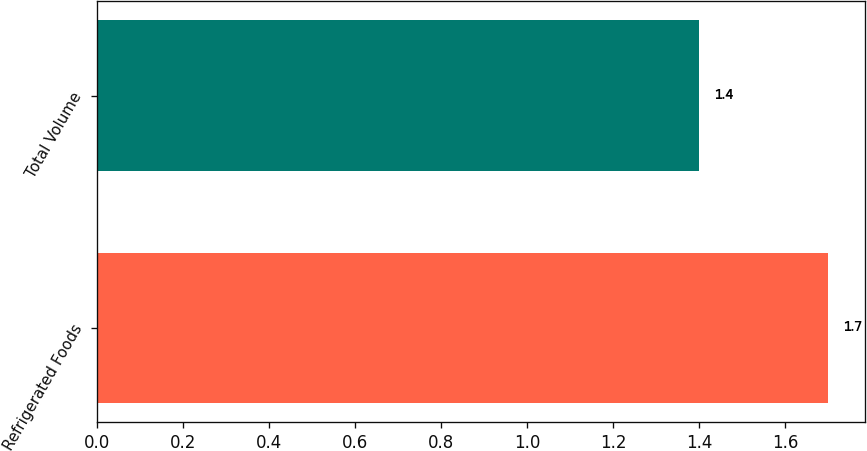Convert chart. <chart><loc_0><loc_0><loc_500><loc_500><bar_chart><fcel>Refrigerated Foods<fcel>Total Volume<nl><fcel>1.7<fcel>1.4<nl></chart> 